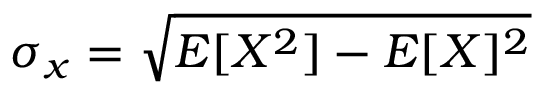<formula> <loc_0><loc_0><loc_500><loc_500>\sigma _ { x } = \sqrt { E [ X ^ { 2 } ] - E [ X ] ^ { 2 } }</formula> 